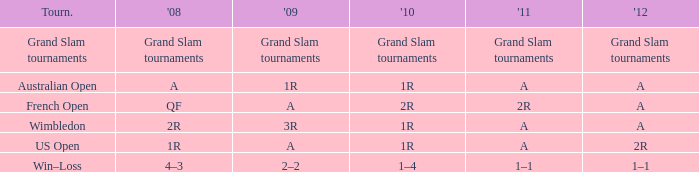Name the 2010 for tournament of us open 1R. 